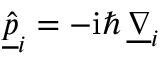Convert formula to latex. <formula><loc_0><loc_0><loc_500><loc_500>\underline { { \hat { p } } } _ { i } = - i \hbar { \, } \underline { \nabla } _ { i }</formula> 